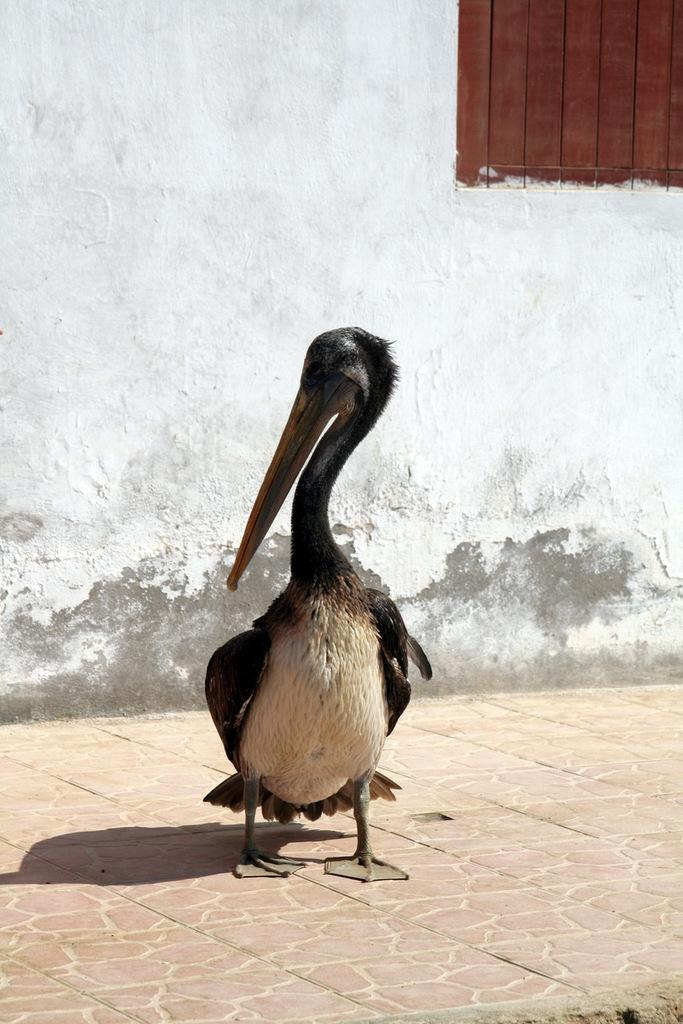What type of animal can be seen in the image? There is a bird in the image. What structure is visible in the image? There is a wall in the image. Can you describe a feature of the wall? There is a window in the wall. What type of front does the bird represent in the image? The bird does not represent any front in the image; it is simply a bird. 